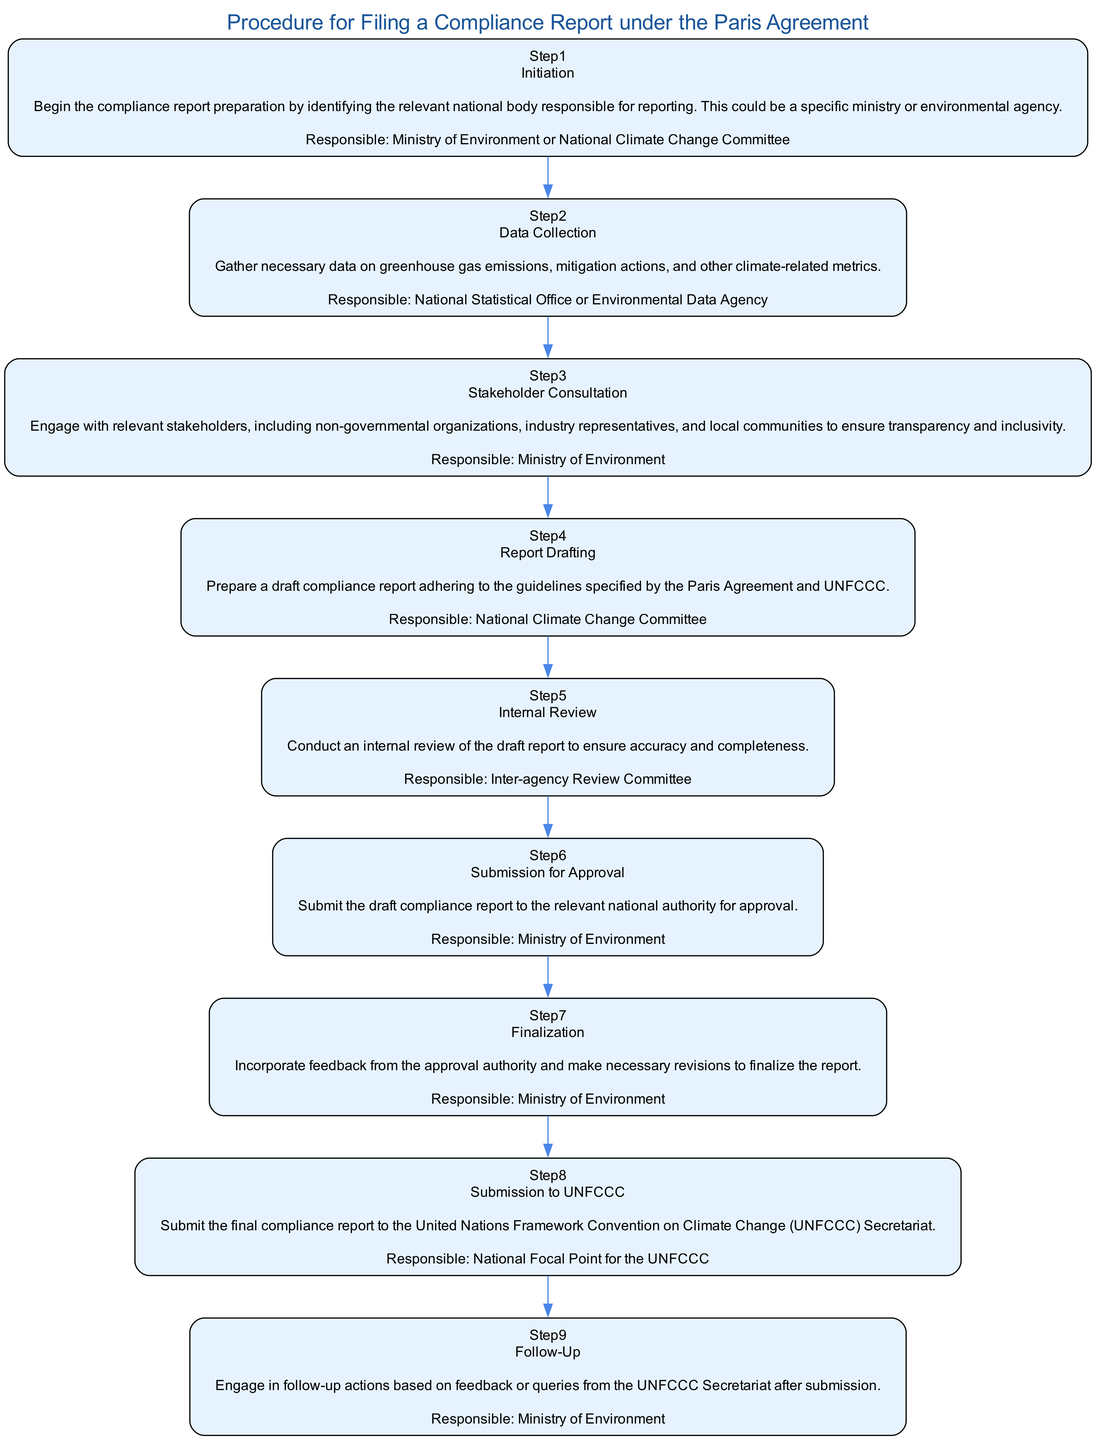What is the first step in the procedure? The first step is labeled "Step1" in the diagram, indicating that it is the initial phase, which is "Initiation."
Answer: Initiation Who is the responsible entity for the data collection step? The diagram specifies under "Step2" related to data collection that the National Statistical Office or Environmental Data Agency is responsible for this phase.
Answer: National Statistical Office or Environmental Data Agency How many total steps are in the compliance report procedure? By counting each step labeled from Step1 to Step9 in the diagram, the total number of steps is nine.
Answer: 9 What follows after the internal review step? In the diagram, "Step5," which corresponds to the internal review, is followed by "Step6," indicating the next step is submission for approval.
Answer: Submission for Approval Which step involves stakeholder consultation? The diagram clearly indicates in "Step3" that stakeholder consultation is part of the process, explicitly mentioning the element on that step.
Answer: Stakeholder Consultation What is the last step of the compliance reporting procedure? The final step is represented as "Step9" in the diagram, indicating the last action is follow-up engagement based on feedback.
Answer: Follow-Up Who handles the drafting of the compliance report? The diagram specifies that "Step4" is where the National Climate Change Committee is responsible for report drafting.
Answer: National Climate Change Committee Which entity is involved in the final submission to the UNFCCC? According to "Step8" in the diagram, the National Focal Point for the UNFCCC is tasked with submitting the final compliance report.
Answer: National Focal Point for the UNFCCC What does the engagement in follow-up actions pertain to? The diagram shows that follow-up actions in "Step9" are based on feedback or queries from the UNFCCC Secretariat following submission.
Answer: Feedback or queries from the UNFCCC Secretariat 